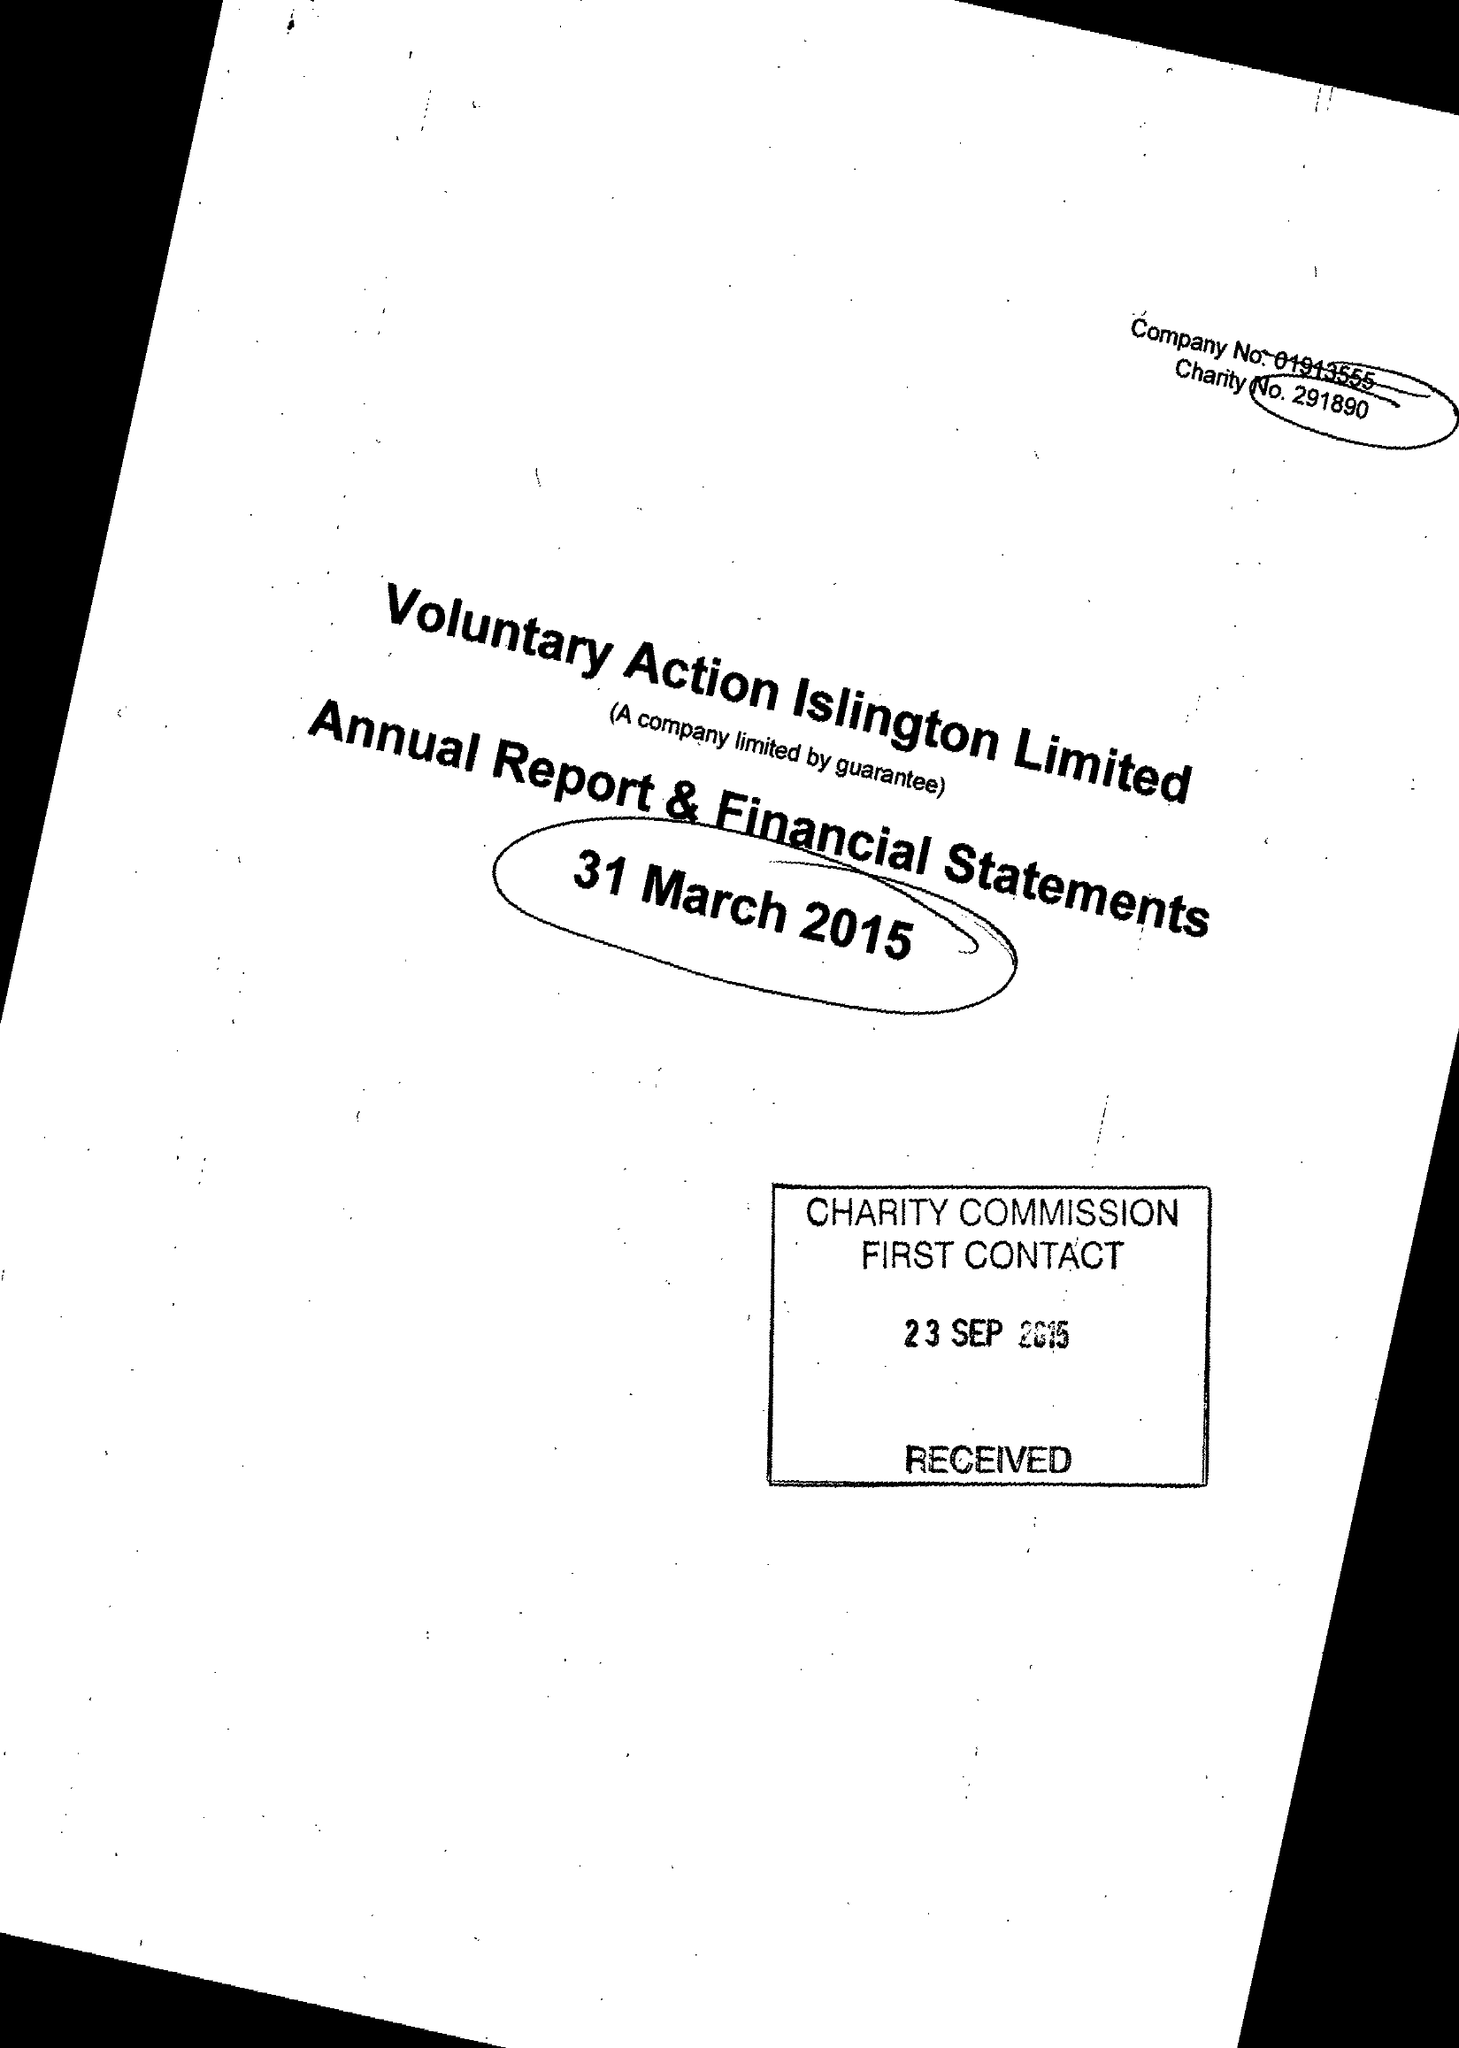What is the value for the charity_name?
Answer the question using a single word or phrase. Voluntary Action Islington Ltd. 